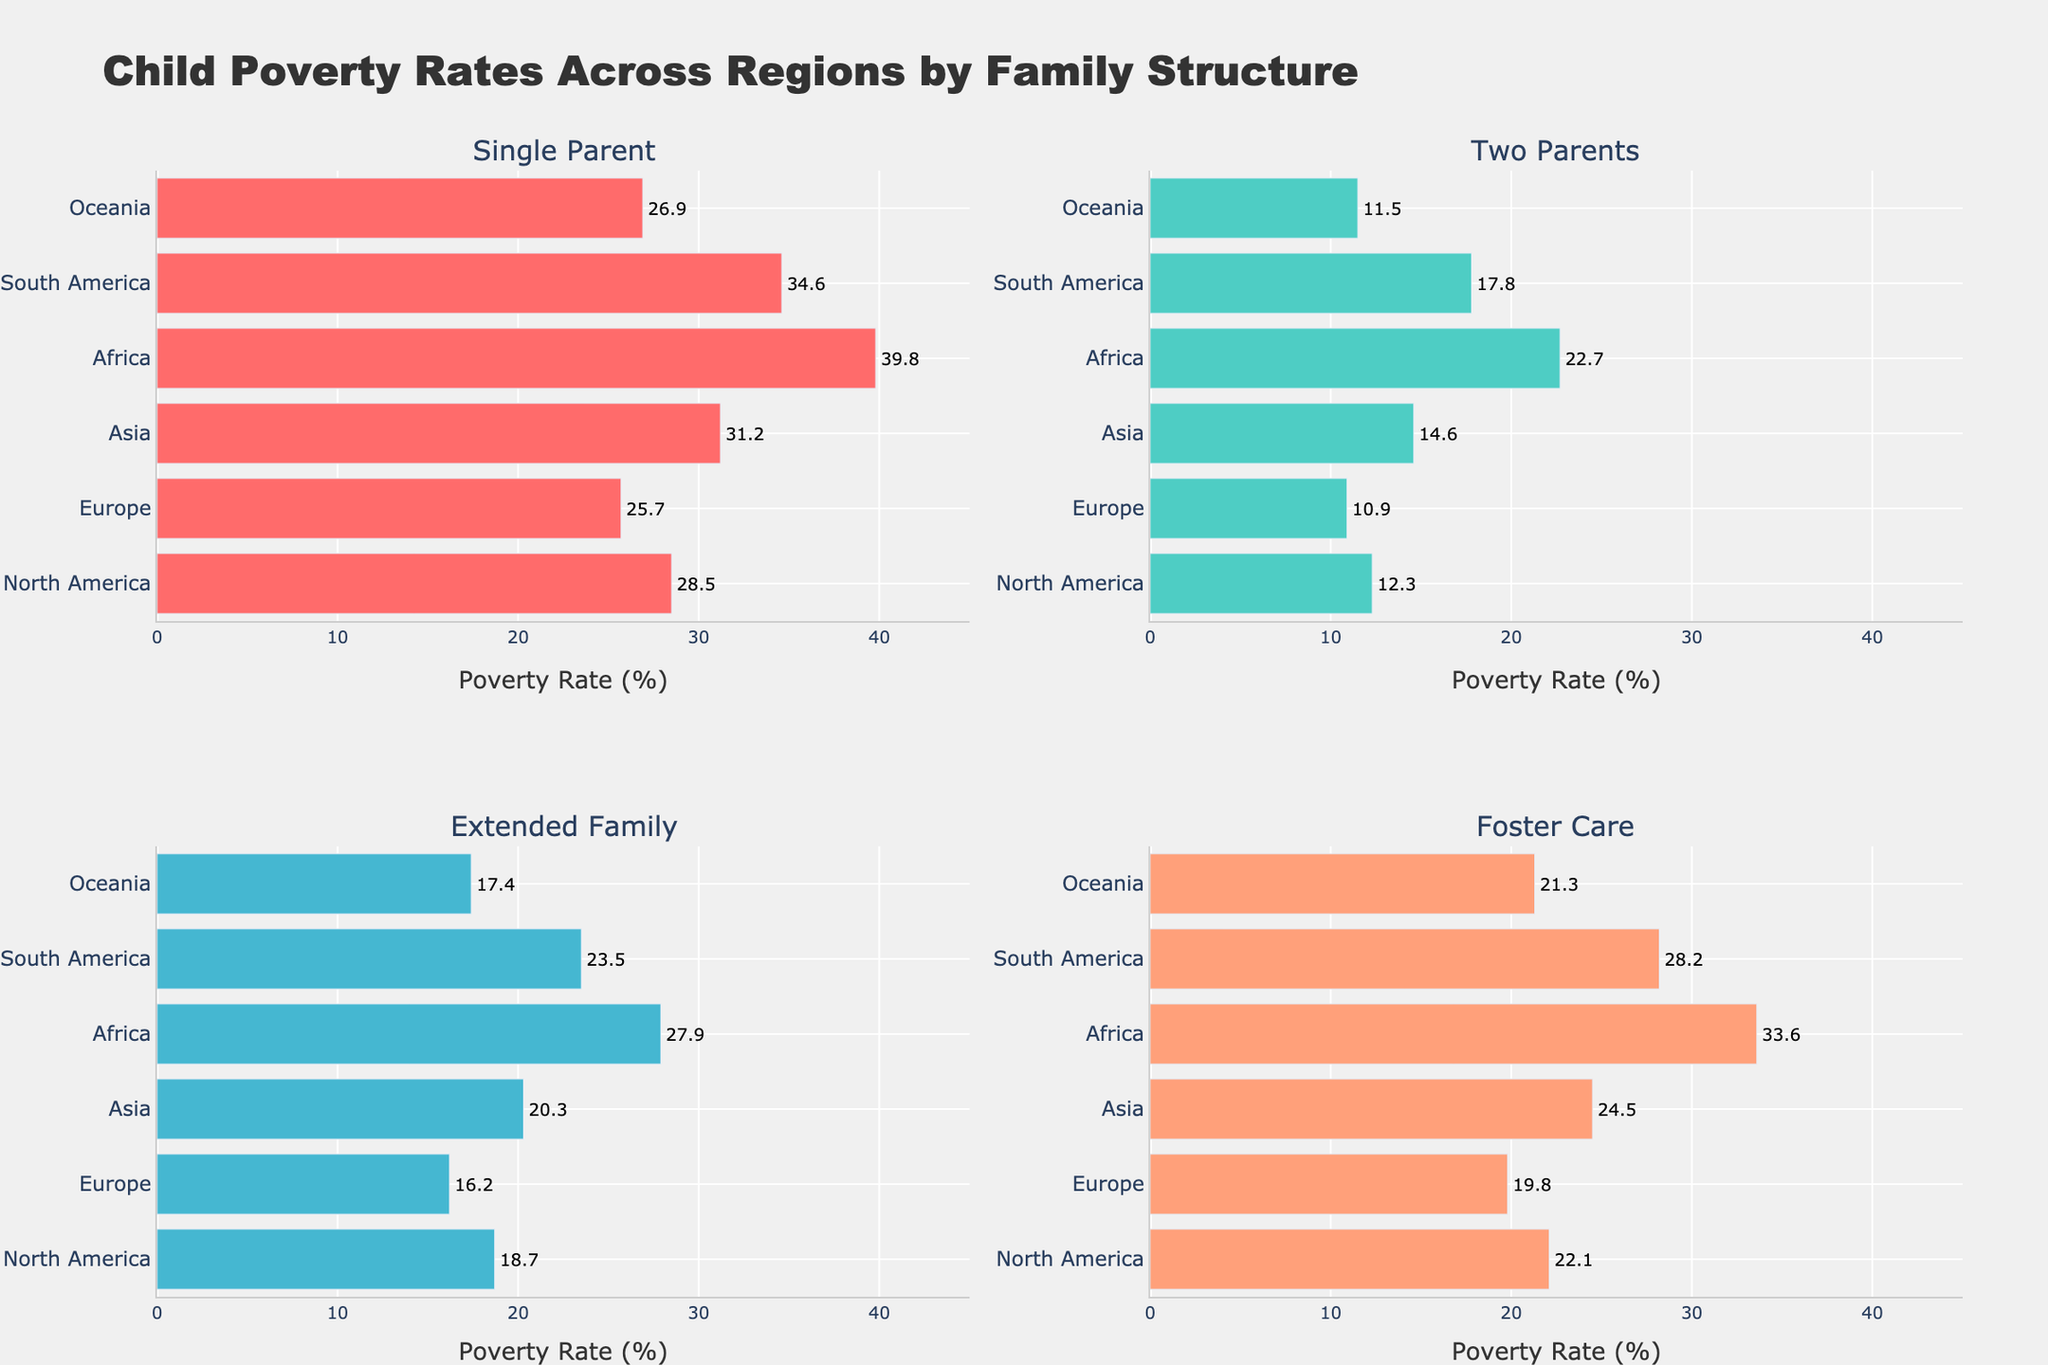What's the title of the figure? The title is placed at the top of the figure above the subplots. It indicates the subject and context of the data presented in the figure.
Answer: Child Poverty Rates Across Regions by Family Structure How many family structures are analyzed in each region? Counting the subplot titles reveals there are four bars corresponding to different family structures: Single Parent, Two Parents, Extended Family, and Foster Care.
Answer: 4 Which region has the highest child poverty rate for Single Parents? Looking at the Single Parent subplot, the bar for Africa is the longest, indicating the highest value among the regions.
Answer: Africa What is the difference in child poverty rates between Single Parents and Two Parents in Europe? Find the values for Europe under Single Parents (25.7) and Two Parents (10.9) and subtract the latter from the former (25.7 - 10.9).
Answer: 14.8 Which family structure has the lowest child poverty rate in Oceania? Locate the bars for Oceania in each of the four subplots and identify the shortest bar, which corresponds to Two Parents (11.5).
Answer: Two Parents What is the average child poverty rate for Asia across all family structures? Sum the values for Asia (31.2, 14.6, 20.3, 24.5) and divide by the number of family structures (4): (31.2 + 14.6 + 20.3 + 24.5) / 4.
Answer: 22.65 In which region is the child poverty rate for Foster Care higher than that for Extended Family? Compare the bars for Foster Care and Extended Family in each subplot. Only Africa and South America show higher values for Foster Care than Extended Family.
Answer: Africa, South America Are there any regions where the child poverty rate for Two Parents exceeds 20%? Look at the Two Parents subplot and identify if any of the regions' bars exceed the 20% mark. Only Africa (22.7) meets this condition.
Answer: Africa What is the range of child poverty rates for Foster Care across all regions? Identify the highest (33.6) and lowest (19.8) values in the Foster Care subplot, then subtract the lowest from the highest (33.6 - 19.8).
Answer: 13.8 Which family structure consistently shows lower child poverty rates across all regions? Compare all four family structure subplots and note that the Two Parents bars are consistently smaller than those of other family structures.
Answer: Two Parents 